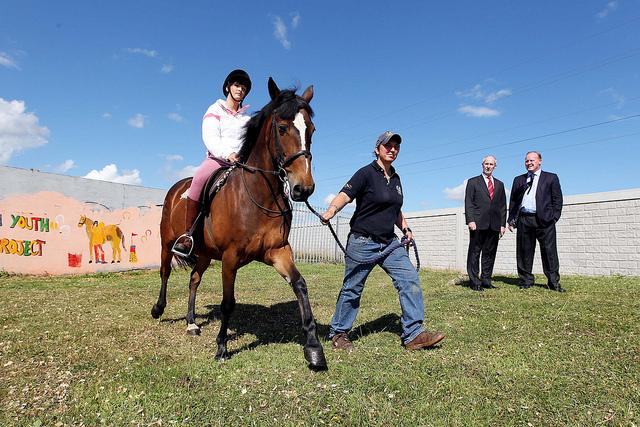Is this a training facility or a youth outreach?
Concise answer only. Youth outreach. What is the one person riding on?
Give a very brief answer. Horse. Are the men on the right hand side dressed professionally?
Be succinct. Yes. Is there snow in this picture?
Short answer required. No. 